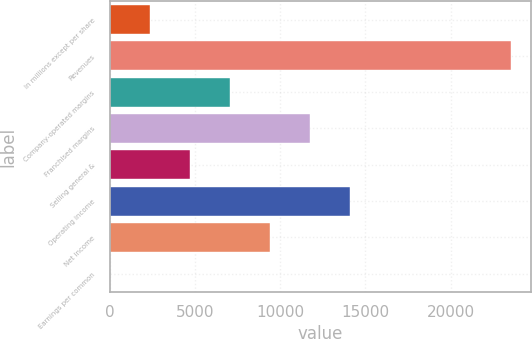Convert chart to OTSL. <chart><loc_0><loc_0><loc_500><loc_500><bar_chart><fcel>In millions except per share<fcel>Revenues<fcel>Company-operated margins<fcel>Franchised margins<fcel>Selling general &<fcel>Operating income<fcel>Net income<fcel>Earnings per common<nl><fcel>2355.58<fcel>23522<fcel>7059.22<fcel>11762.9<fcel>4707.4<fcel>14114.7<fcel>9411.04<fcel>3.76<nl></chart> 